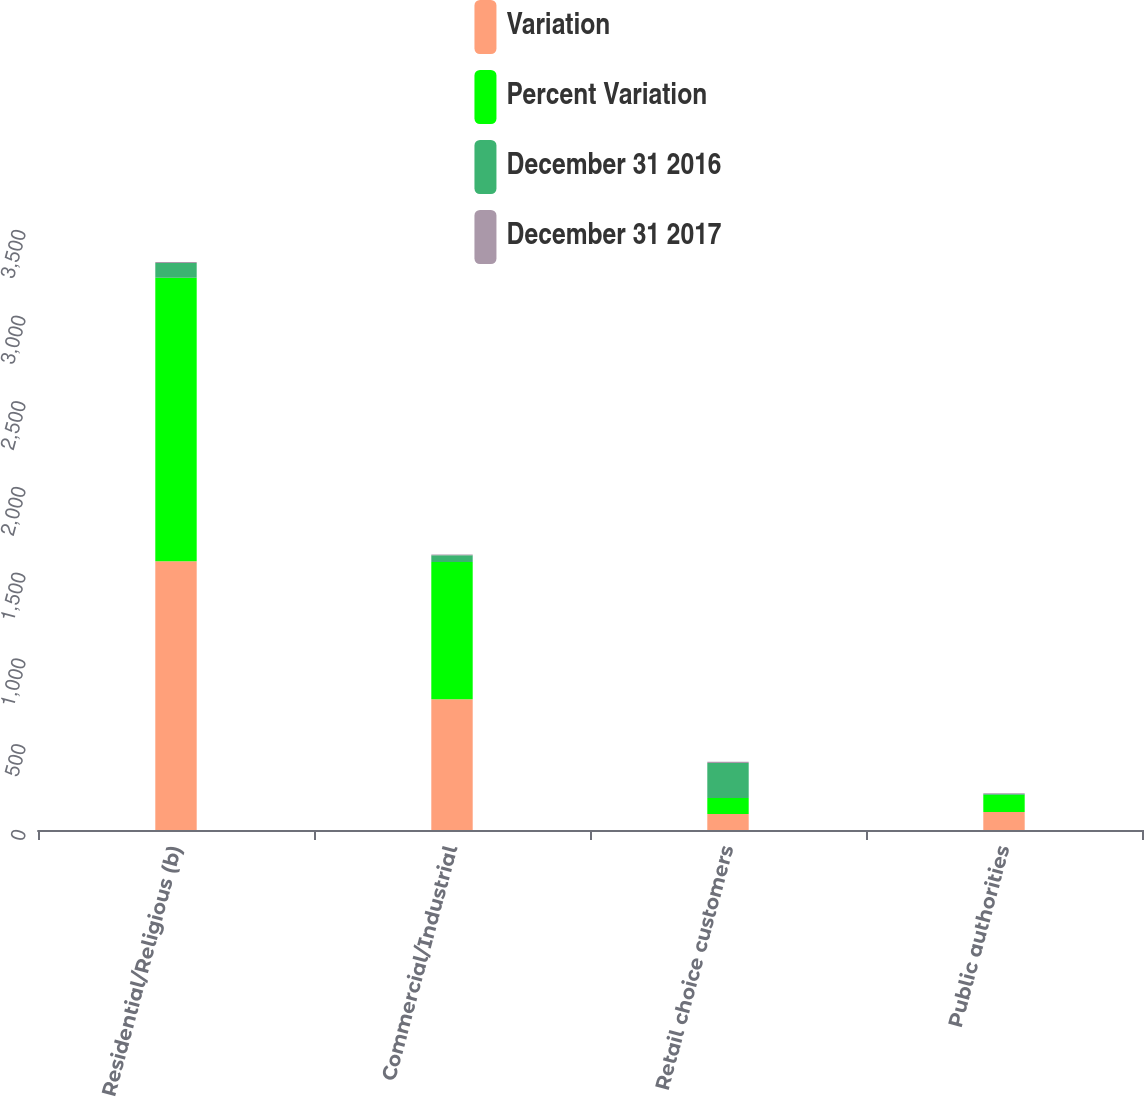Convert chart to OTSL. <chart><loc_0><loc_0><loc_500><loc_500><stacked_bar_chart><ecel><fcel>Residential/Religious (b)<fcel>Commercial/Industrial<fcel>Retail choice customers<fcel>Public authorities<nl><fcel>Variation<fcel>1567<fcel>763<fcel>93.5<fcel>105<nl><fcel>Percent Variation<fcel>1654<fcel>801<fcel>93.5<fcel>100<nl><fcel>December 31 2016<fcel>87<fcel>38<fcel>204<fcel>5<nl><fcel>December 31 2017<fcel>5.3<fcel>4.7<fcel>6.4<fcel>5<nl></chart> 